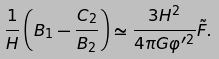Convert formula to latex. <formula><loc_0><loc_0><loc_500><loc_500>\frac { 1 } { H } \left ( B _ { 1 } - \frac { C _ { 2 } } { B _ { 2 } } \right ) \simeq \frac { 3 H ^ { 2 } } { 4 \pi G \varphi ^ { \prime 2 } } \tilde { F } .</formula> 